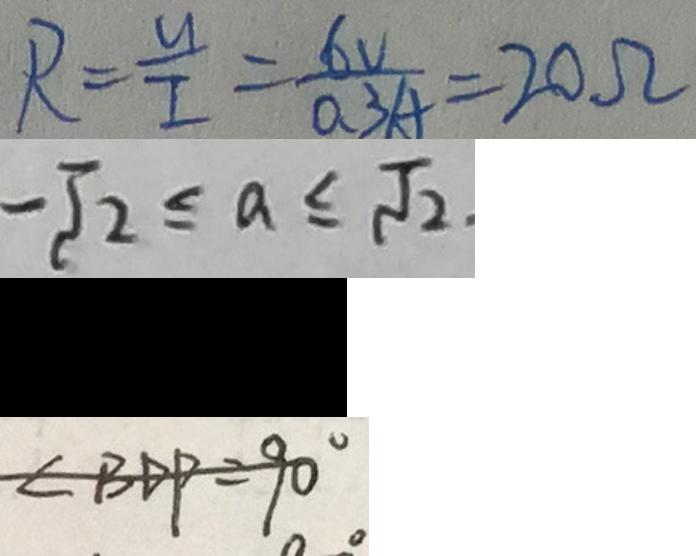Convert formula to latex. <formula><loc_0><loc_0><loc_500><loc_500>R = \frac { u } { I } = \frac { 6 V } { 0 . 3 A } = 2 0 \Omega 
 - \sqrt { 2 } \leq a \leq \sqrt { 2 } . 
 ( 2 ) \frac { 3 } { x ^ { 2 } + 2 x y + y ^ { 2 } } - 
 \angle B D P = 9 0 ^ { \circ }</formula> 